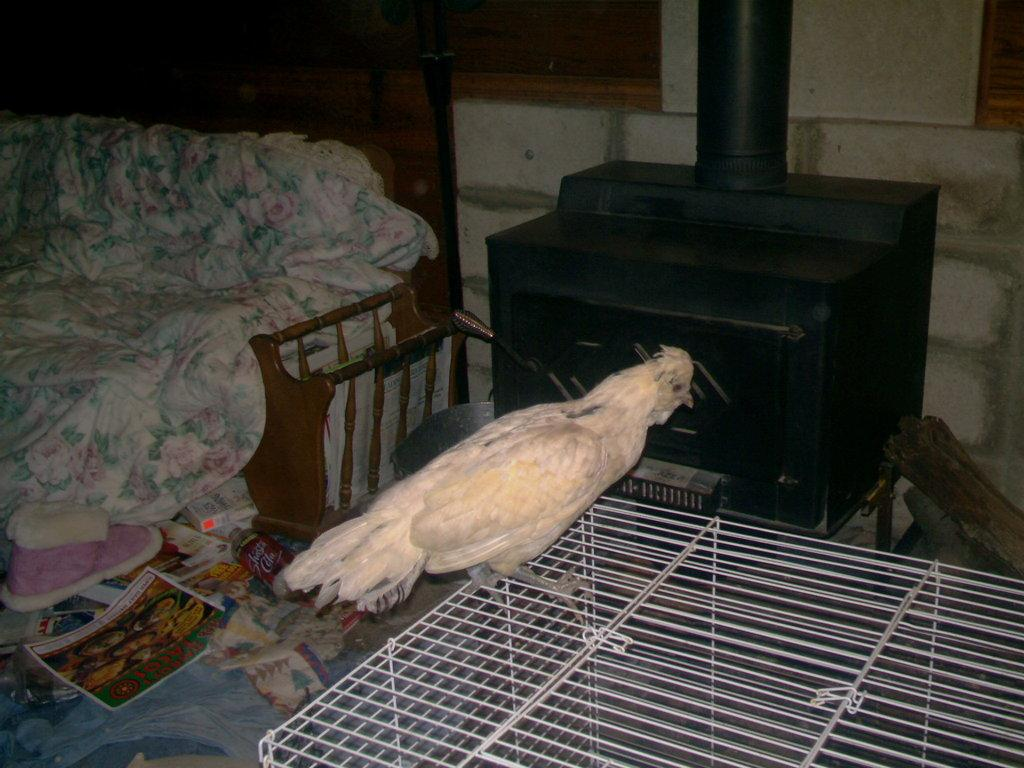Where is the image taken? The image is taken in a room. What animal can be seen in the image? There is a bird in the image. What is the bird standing on? The bird is standing on a cage. What furniture is visible behind the bird? There is a sofa behind the bird. What can be seen in the background of the image? There is a cloth and a table in the background. What type of seed is the bird eating in the image? There is no seed present in the image, and the bird is not shown eating anything. 